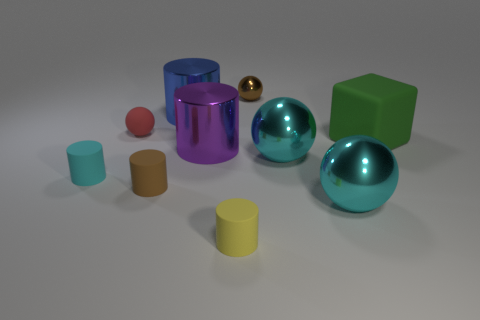Subtract all cyan balls. How many gray cubes are left? 0 Subtract all big things. Subtract all purple things. How many objects are left? 4 Add 3 brown matte cylinders. How many brown matte cylinders are left? 4 Add 4 big gray matte objects. How many big gray matte objects exist? 4 Subtract all blue cylinders. How many cylinders are left? 4 Subtract all blue metal cylinders. How many cylinders are left? 4 Subtract 0 yellow blocks. How many objects are left? 10 Subtract all blocks. How many objects are left? 9 Subtract 2 spheres. How many spheres are left? 2 Subtract all yellow cylinders. Subtract all yellow blocks. How many cylinders are left? 4 